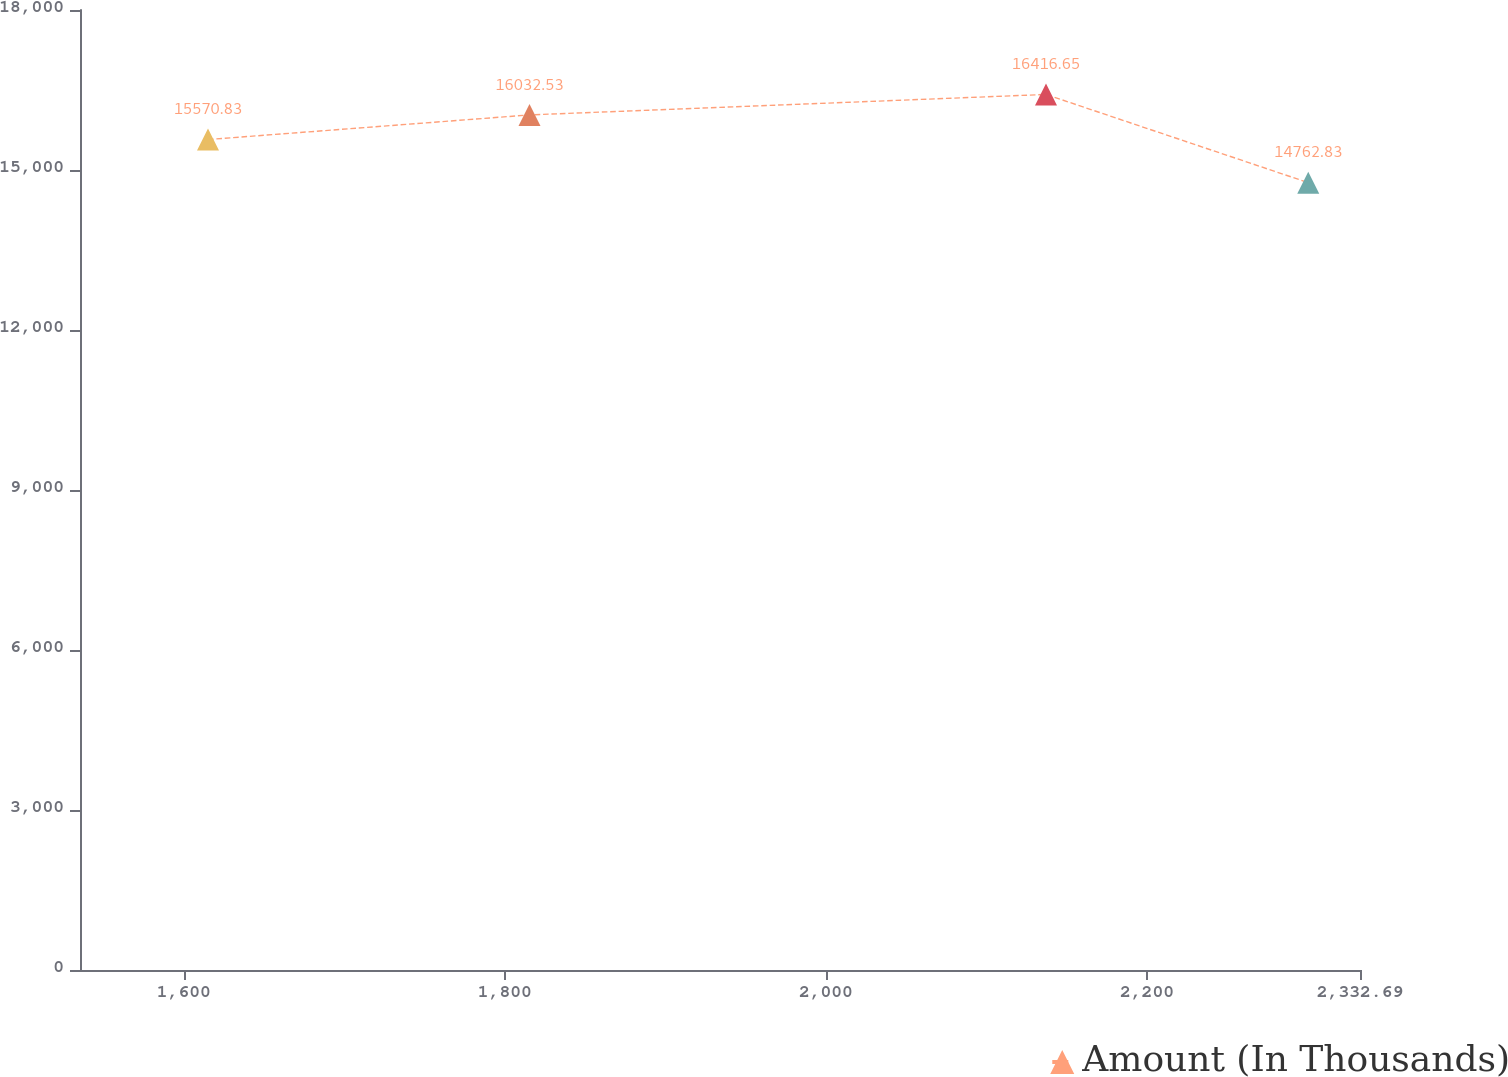Convert chart. <chart><loc_0><loc_0><loc_500><loc_500><line_chart><ecel><fcel>Amount (In Thousands)<nl><fcel>1615.12<fcel>15570.8<nl><fcel>1815.38<fcel>16032.5<nl><fcel>2137.09<fcel>16416.7<nl><fcel>2300.45<fcel>14762.8<nl><fcel>2412.42<fcel>14579.1<nl></chart> 